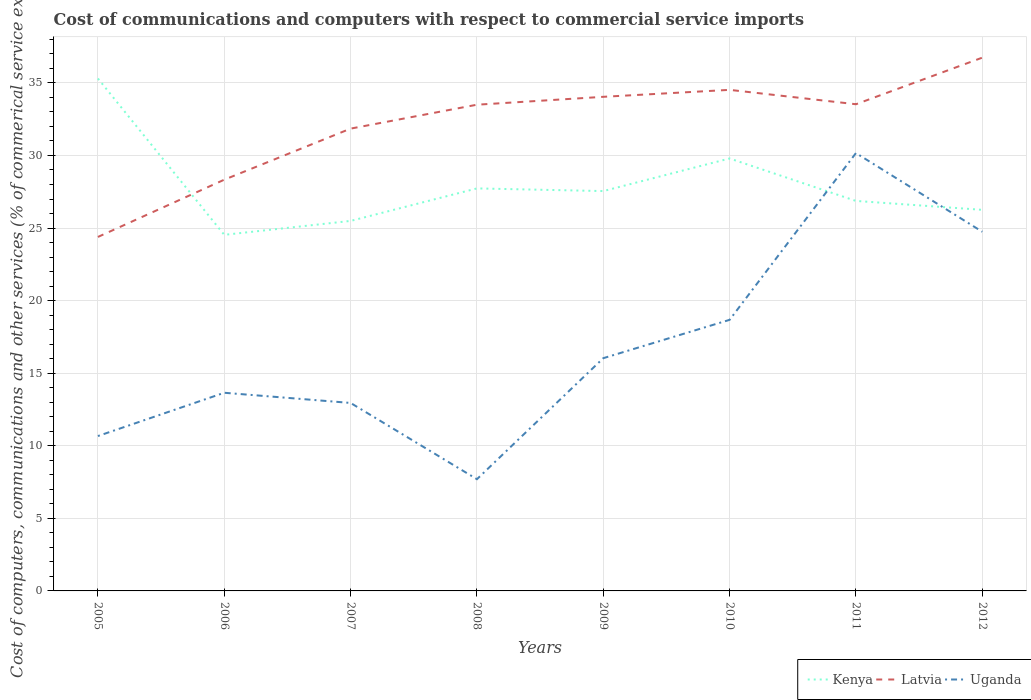Does the line corresponding to Latvia intersect with the line corresponding to Kenya?
Make the answer very short. Yes. Is the number of lines equal to the number of legend labels?
Ensure brevity in your answer.  Yes. Across all years, what is the maximum cost of communications and computers in Kenya?
Ensure brevity in your answer.  24.53. In which year was the cost of communications and computers in Kenya maximum?
Offer a terse response. 2006. What is the total cost of communications and computers in Kenya in the graph?
Your answer should be compact. -4.3. What is the difference between the highest and the second highest cost of communications and computers in Latvia?
Your answer should be very brief. 12.35. What is the difference between the highest and the lowest cost of communications and computers in Kenya?
Offer a very short reply. 2. How many lines are there?
Provide a short and direct response. 3. How many years are there in the graph?
Offer a very short reply. 8. Are the values on the major ticks of Y-axis written in scientific E-notation?
Your answer should be compact. No. How are the legend labels stacked?
Offer a very short reply. Horizontal. What is the title of the graph?
Your answer should be compact. Cost of communications and computers with respect to commercial service imports. What is the label or title of the X-axis?
Give a very brief answer. Years. What is the label or title of the Y-axis?
Provide a short and direct response. Cost of computers, communications and other services (% of commerical service exports). What is the Cost of computers, communications and other services (% of commerical service exports) of Kenya in 2005?
Your answer should be very brief. 35.3. What is the Cost of computers, communications and other services (% of commerical service exports) in Latvia in 2005?
Your response must be concise. 24.39. What is the Cost of computers, communications and other services (% of commerical service exports) in Uganda in 2005?
Offer a very short reply. 10.67. What is the Cost of computers, communications and other services (% of commerical service exports) of Kenya in 2006?
Offer a very short reply. 24.53. What is the Cost of computers, communications and other services (% of commerical service exports) in Latvia in 2006?
Keep it short and to the point. 28.33. What is the Cost of computers, communications and other services (% of commerical service exports) in Uganda in 2006?
Provide a succinct answer. 13.65. What is the Cost of computers, communications and other services (% of commerical service exports) of Kenya in 2007?
Your response must be concise. 25.49. What is the Cost of computers, communications and other services (% of commerical service exports) of Latvia in 2007?
Make the answer very short. 31.85. What is the Cost of computers, communications and other services (% of commerical service exports) of Uganda in 2007?
Provide a succinct answer. 12.95. What is the Cost of computers, communications and other services (% of commerical service exports) of Kenya in 2008?
Provide a succinct answer. 27.73. What is the Cost of computers, communications and other services (% of commerical service exports) of Latvia in 2008?
Provide a short and direct response. 33.5. What is the Cost of computers, communications and other services (% of commerical service exports) in Uganda in 2008?
Give a very brief answer. 7.7. What is the Cost of computers, communications and other services (% of commerical service exports) in Kenya in 2009?
Your response must be concise. 27.55. What is the Cost of computers, communications and other services (% of commerical service exports) in Latvia in 2009?
Keep it short and to the point. 34.04. What is the Cost of computers, communications and other services (% of commerical service exports) in Uganda in 2009?
Give a very brief answer. 16.03. What is the Cost of computers, communications and other services (% of commerical service exports) of Kenya in 2010?
Your answer should be very brief. 29.79. What is the Cost of computers, communications and other services (% of commerical service exports) of Latvia in 2010?
Make the answer very short. 34.52. What is the Cost of computers, communications and other services (% of commerical service exports) of Uganda in 2010?
Your answer should be very brief. 18.68. What is the Cost of computers, communications and other services (% of commerical service exports) of Kenya in 2011?
Keep it short and to the point. 26.87. What is the Cost of computers, communications and other services (% of commerical service exports) in Latvia in 2011?
Your response must be concise. 33.53. What is the Cost of computers, communications and other services (% of commerical service exports) in Uganda in 2011?
Your response must be concise. 30.17. What is the Cost of computers, communications and other services (% of commerical service exports) of Kenya in 2012?
Your response must be concise. 26.25. What is the Cost of computers, communications and other services (% of commerical service exports) of Latvia in 2012?
Provide a short and direct response. 36.74. What is the Cost of computers, communications and other services (% of commerical service exports) of Uganda in 2012?
Make the answer very short. 24.74. Across all years, what is the maximum Cost of computers, communications and other services (% of commerical service exports) of Kenya?
Provide a short and direct response. 35.3. Across all years, what is the maximum Cost of computers, communications and other services (% of commerical service exports) of Latvia?
Ensure brevity in your answer.  36.74. Across all years, what is the maximum Cost of computers, communications and other services (% of commerical service exports) in Uganda?
Offer a very short reply. 30.17. Across all years, what is the minimum Cost of computers, communications and other services (% of commerical service exports) in Kenya?
Offer a terse response. 24.53. Across all years, what is the minimum Cost of computers, communications and other services (% of commerical service exports) in Latvia?
Provide a succinct answer. 24.39. Across all years, what is the minimum Cost of computers, communications and other services (% of commerical service exports) in Uganda?
Offer a very short reply. 7.7. What is the total Cost of computers, communications and other services (% of commerical service exports) in Kenya in the graph?
Offer a very short reply. 223.52. What is the total Cost of computers, communications and other services (% of commerical service exports) in Latvia in the graph?
Your answer should be very brief. 256.89. What is the total Cost of computers, communications and other services (% of commerical service exports) in Uganda in the graph?
Give a very brief answer. 134.59. What is the difference between the Cost of computers, communications and other services (% of commerical service exports) in Kenya in 2005 and that in 2006?
Offer a very short reply. 10.77. What is the difference between the Cost of computers, communications and other services (% of commerical service exports) of Latvia in 2005 and that in 2006?
Ensure brevity in your answer.  -3.94. What is the difference between the Cost of computers, communications and other services (% of commerical service exports) of Uganda in 2005 and that in 2006?
Give a very brief answer. -2.98. What is the difference between the Cost of computers, communications and other services (% of commerical service exports) of Kenya in 2005 and that in 2007?
Ensure brevity in your answer.  9.81. What is the difference between the Cost of computers, communications and other services (% of commerical service exports) of Latvia in 2005 and that in 2007?
Provide a short and direct response. -7.46. What is the difference between the Cost of computers, communications and other services (% of commerical service exports) of Uganda in 2005 and that in 2007?
Keep it short and to the point. -2.28. What is the difference between the Cost of computers, communications and other services (% of commerical service exports) in Kenya in 2005 and that in 2008?
Ensure brevity in your answer.  7.57. What is the difference between the Cost of computers, communications and other services (% of commerical service exports) of Latvia in 2005 and that in 2008?
Offer a very short reply. -9.11. What is the difference between the Cost of computers, communications and other services (% of commerical service exports) of Uganda in 2005 and that in 2008?
Offer a very short reply. 2.97. What is the difference between the Cost of computers, communications and other services (% of commerical service exports) in Kenya in 2005 and that in 2009?
Keep it short and to the point. 7.75. What is the difference between the Cost of computers, communications and other services (% of commerical service exports) of Latvia in 2005 and that in 2009?
Your response must be concise. -9.65. What is the difference between the Cost of computers, communications and other services (% of commerical service exports) of Uganda in 2005 and that in 2009?
Provide a short and direct response. -5.36. What is the difference between the Cost of computers, communications and other services (% of commerical service exports) of Kenya in 2005 and that in 2010?
Your answer should be compact. 5.51. What is the difference between the Cost of computers, communications and other services (% of commerical service exports) of Latvia in 2005 and that in 2010?
Your answer should be very brief. -10.13. What is the difference between the Cost of computers, communications and other services (% of commerical service exports) of Uganda in 2005 and that in 2010?
Provide a short and direct response. -8.01. What is the difference between the Cost of computers, communications and other services (% of commerical service exports) of Kenya in 2005 and that in 2011?
Ensure brevity in your answer.  8.43. What is the difference between the Cost of computers, communications and other services (% of commerical service exports) in Latvia in 2005 and that in 2011?
Offer a very short reply. -9.14. What is the difference between the Cost of computers, communications and other services (% of commerical service exports) in Uganda in 2005 and that in 2011?
Make the answer very short. -19.5. What is the difference between the Cost of computers, communications and other services (% of commerical service exports) of Kenya in 2005 and that in 2012?
Provide a succinct answer. 9.05. What is the difference between the Cost of computers, communications and other services (% of commerical service exports) in Latvia in 2005 and that in 2012?
Offer a terse response. -12.35. What is the difference between the Cost of computers, communications and other services (% of commerical service exports) in Uganda in 2005 and that in 2012?
Your answer should be compact. -14.07. What is the difference between the Cost of computers, communications and other services (% of commerical service exports) in Kenya in 2006 and that in 2007?
Your answer should be very brief. -0.96. What is the difference between the Cost of computers, communications and other services (% of commerical service exports) of Latvia in 2006 and that in 2007?
Give a very brief answer. -3.52. What is the difference between the Cost of computers, communications and other services (% of commerical service exports) of Uganda in 2006 and that in 2007?
Your response must be concise. 0.7. What is the difference between the Cost of computers, communications and other services (% of commerical service exports) in Kenya in 2006 and that in 2008?
Offer a very short reply. -3.2. What is the difference between the Cost of computers, communications and other services (% of commerical service exports) of Latvia in 2006 and that in 2008?
Keep it short and to the point. -5.17. What is the difference between the Cost of computers, communications and other services (% of commerical service exports) of Uganda in 2006 and that in 2008?
Your answer should be very brief. 5.95. What is the difference between the Cost of computers, communications and other services (% of commerical service exports) in Kenya in 2006 and that in 2009?
Offer a very short reply. -3.02. What is the difference between the Cost of computers, communications and other services (% of commerical service exports) of Latvia in 2006 and that in 2009?
Make the answer very short. -5.71. What is the difference between the Cost of computers, communications and other services (% of commerical service exports) in Uganda in 2006 and that in 2009?
Provide a short and direct response. -2.38. What is the difference between the Cost of computers, communications and other services (% of commerical service exports) in Kenya in 2006 and that in 2010?
Offer a very short reply. -5.26. What is the difference between the Cost of computers, communications and other services (% of commerical service exports) of Latvia in 2006 and that in 2010?
Offer a terse response. -6.19. What is the difference between the Cost of computers, communications and other services (% of commerical service exports) of Uganda in 2006 and that in 2010?
Your response must be concise. -5.02. What is the difference between the Cost of computers, communications and other services (% of commerical service exports) in Kenya in 2006 and that in 2011?
Provide a succinct answer. -2.34. What is the difference between the Cost of computers, communications and other services (% of commerical service exports) of Latvia in 2006 and that in 2011?
Give a very brief answer. -5.2. What is the difference between the Cost of computers, communications and other services (% of commerical service exports) of Uganda in 2006 and that in 2011?
Provide a succinct answer. -16.51. What is the difference between the Cost of computers, communications and other services (% of commerical service exports) in Kenya in 2006 and that in 2012?
Make the answer very short. -1.72. What is the difference between the Cost of computers, communications and other services (% of commerical service exports) in Latvia in 2006 and that in 2012?
Offer a very short reply. -8.41. What is the difference between the Cost of computers, communications and other services (% of commerical service exports) in Uganda in 2006 and that in 2012?
Provide a short and direct response. -11.09. What is the difference between the Cost of computers, communications and other services (% of commerical service exports) of Kenya in 2007 and that in 2008?
Provide a short and direct response. -2.24. What is the difference between the Cost of computers, communications and other services (% of commerical service exports) in Latvia in 2007 and that in 2008?
Provide a succinct answer. -1.65. What is the difference between the Cost of computers, communications and other services (% of commerical service exports) of Uganda in 2007 and that in 2008?
Your response must be concise. 5.25. What is the difference between the Cost of computers, communications and other services (% of commerical service exports) in Kenya in 2007 and that in 2009?
Make the answer very short. -2.06. What is the difference between the Cost of computers, communications and other services (% of commerical service exports) in Latvia in 2007 and that in 2009?
Offer a very short reply. -2.19. What is the difference between the Cost of computers, communications and other services (% of commerical service exports) of Uganda in 2007 and that in 2009?
Make the answer very short. -3.08. What is the difference between the Cost of computers, communications and other services (% of commerical service exports) in Kenya in 2007 and that in 2010?
Provide a short and direct response. -4.3. What is the difference between the Cost of computers, communications and other services (% of commerical service exports) of Latvia in 2007 and that in 2010?
Ensure brevity in your answer.  -2.67. What is the difference between the Cost of computers, communications and other services (% of commerical service exports) in Uganda in 2007 and that in 2010?
Your response must be concise. -5.73. What is the difference between the Cost of computers, communications and other services (% of commerical service exports) of Kenya in 2007 and that in 2011?
Provide a succinct answer. -1.38. What is the difference between the Cost of computers, communications and other services (% of commerical service exports) of Latvia in 2007 and that in 2011?
Your answer should be very brief. -1.68. What is the difference between the Cost of computers, communications and other services (% of commerical service exports) in Uganda in 2007 and that in 2011?
Your answer should be very brief. -17.22. What is the difference between the Cost of computers, communications and other services (% of commerical service exports) of Kenya in 2007 and that in 2012?
Make the answer very short. -0.76. What is the difference between the Cost of computers, communications and other services (% of commerical service exports) in Latvia in 2007 and that in 2012?
Make the answer very short. -4.89. What is the difference between the Cost of computers, communications and other services (% of commerical service exports) of Uganda in 2007 and that in 2012?
Provide a short and direct response. -11.79. What is the difference between the Cost of computers, communications and other services (% of commerical service exports) of Kenya in 2008 and that in 2009?
Offer a terse response. 0.18. What is the difference between the Cost of computers, communications and other services (% of commerical service exports) of Latvia in 2008 and that in 2009?
Give a very brief answer. -0.54. What is the difference between the Cost of computers, communications and other services (% of commerical service exports) of Uganda in 2008 and that in 2009?
Your response must be concise. -8.34. What is the difference between the Cost of computers, communications and other services (% of commerical service exports) of Kenya in 2008 and that in 2010?
Keep it short and to the point. -2.06. What is the difference between the Cost of computers, communications and other services (% of commerical service exports) in Latvia in 2008 and that in 2010?
Offer a very short reply. -1.02. What is the difference between the Cost of computers, communications and other services (% of commerical service exports) of Uganda in 2008 and that in 2010?
Your answer should be very brief. -10.98. What is the difference between the Cost of computers, communications and other services (% of commerical service exports) in Kenya in 2008 and that in 2011?
Give a very brief answer. 0.86. What is the difference between the Cost of computers, communications and other services (% of commerical service exports) of Latvia in 2008 and that in 2011?
Your answer should be very brief. -0.03. What is the difference between the Cost of computers, communications and other services (% of commerical service exports) of Uganda in 2008 and that in 2011?
Offer a very short reply. -22.47. What is the difference between the Cost of computers, communications and other services (% of commerical service exports) in Kenya in 2008 and that in 2012?
Give a very brief answer. 1.48. What is the difference between the Cost of computers, communications and other services (% of commerical service exports) in Latvia in 2008 and that in 2012?
Keep it short and to the point. -3.24. What is the difference between the Cost of computers, communications and other services (% of commerical service exports) of Uganda in 2008 and that in 2012?
Provide a short and direct response. -17.05. What is the difference between the Cost of computers, communications and other services (% of commerical service exports) of Kenya in 2009 and that in 2010?
Offer a very short reply. -2.25. What is the difference between the Cost of computers, communications and other services (% of commerical service exports) in Latvia in 2009 and that in 2010?
Your answer should be very brief. -0.48. What is the difference between the Cost of computers, communications and other services (% of commerical service exports) in Uganda in 2009 and that in 2010?
Keep it short and to the point. -2.64. What is the difference between the Cost of computers, communications and other services (% of commerical service exports) of Kenya in 2009 and that in 2011?
Your answer should be compact. 0.68. What is the difference between the Cost of computers, communications and other services (% of commerical service exports) in Latvia in 2009 and that in 2011?
Your response must be concise. 0.51. What is the difference between the Cost of computers, communications and other services (% of commerical service exports) in Uganda in 2009 and that in 2011?
Provide a short and direct response. -14.13. What is the difference between the Cost of computers, communications and other services (% of commerical service exports) of Kenya in 2009 and that in 2012?
Your answer should be compact. 1.29. What is the difference between the Cost of computers, communications and other services (% of commerical service exports) of Latvia in 2009 and that in 2012?
Your answer should be compact. -2.7. What is the difference between the Cost of computers, communications and other services (% of commerical service exports) of Uganda in 2009 and that in 2012?
Your answer should be compact. -8.71. What is the difference between the Cost of computers, communications and other services (% of commerical service exports) of Kenya in 2010 and that in 2011?
Offer a very short reply. 2.92. What is the difference between the Cost of computers, communications and other services (% of commerical service exports) of Latvia in 2010 and that in 2011?
Your answer should be very brief. 0.99. What is the difference between the Cost of computers, communications and other services (% of commerical service exports) in Uganda in 2010 and that in 2011?
Make the answer very short. -11.49. What is the difference between the Cost of computers, communications and other services (% of commerical service exports) in Kenya in 2010 and that in 2012?
Offer a very short reply. 3.54. What is the difference between the Cost of computers, communications and other services (% of commerical service exports) of Latvia in 2010 and that in 2012?
Your response must be concise. -2.22. What is the difference between the Cost of computers, communications and other services (% of commerical service exports) in Uganda in 2010 and that in 2012?
Your answer should be very brief. -6.07. What is the difference between the Cost of computers, communications and other services (% of commerical service exports) in Kenya in 2011 and that in 2012?
Keep it short and to the point. 0.61. What is the difference between the Cost of computers, communications and other services (% of commerical service exports) of Latvia in 2011 and that in 2012?
Make the answer very short. -3.21. What is the difference between the Cost of computers, communications and other services (% of commerical service exports) of Uganda in 2011 and that in 2012?
Ensure brevity in your answer.  5.42. What is the difference between the Cost of computers, communications and other services (% of commerical service exports) of Kenya in 2005 and the Cost of computers, communications and other services (% of commerical service exports) of Latvia in 2006?
Give a very brief answer. 6.97. What is the difference between the Cost of computers, communications and other services (% of commerical service exports) in Kenya in 2005 and the Cost of computers, communications and other services (% of commerical service exports) in Uganda in 2006?
Offer a very short reply. 21.65. What is the difference between the Cost of computers, communications and other services (% of commerical service exports) of Latvia in 2005 and the Cost of computers, communications and other services (% of commerical service exports) of Uganda in 2006?
Ensure brevity in your answer.  10.73. What is the difference between the Cost of computers, communications and other services (% of commerical service exports) of Kenya in 2005 and the Cost of computers, communications and other services (% of commerical service exports) of Latvia in 2007?
Provide a short and direct response. 3.45. What is the difference between the Cost of computers, communications and other services (% of commerical service exports) of Kenya in 2005 and the Cost of computers, communications and other services (% of commerical service exports) of Uganda in 2007?
Provide a short and direct response. 22.35. What is the difference between the Cost of computers, communications and other services (% of commerical service exports) of Latvia in 2005 and the Cost of computers, communications and other services (% of commerical service exports) of Uganda in 2007?
Your answer should be very brief. 11.44. What is the difference between the Cost of computers, communications and other services (% of commerical service exports) in Kenya in 2005 and the Cost of computers, communications and other services (% of commerical service exports) in Latvia in 2008?
Provide a short and direct response. 1.8. What is the difference between the Cost of computers, communications and other services (% of commerical service exports) of Kenya in 2005 and the Cost of computers, communications and other services (% of commerical service exports) of Uganda in 2008?
Make the answer very short. 27.6. What is the difference between the Cost of computers, communications and other services (% of commerical service exports) of Latvia in 2005 and the Cost of computers, communications and other services (% of commerical service exports) of Uganda in 2008?
Offer a terse response. 16.69. What is the difference between the Cost of computers, communications and other services (% of commerical service exports) of Kenya in 2005 and the Cost of computers, communications and other services (% of commerical service exports) of Latvia in 2009?
Your answer should be compact. 1.26. What is the difference between the Cost of computers, communications and other services (% of commerical service exports) of Kenya in 2005 and the Cost of computers, communications and other services (% of commerical service exports) of Uganda in 2009?
Ensure brevity in your answer.  19.27. What is the difference between the Cost of computers, communications and other services (% of commerical service exports) in Latvia in 2005 and the Cost of computers, communications and other services (% of commerical service exports) in Uganda in 2009?
Offer a terse response. 8.35. What is the difference between the Cost of computers, communications and other services (% of commerical service exports) in Kenya in 2005 and the Cost of computers, communications and other services (% of commerical service exports) in Latvia in 2010?
Provide a short and direct response. 0.78. What is the difference between the Cost of computers, communications and other services (% of commerical service exports) of Kenya in 2005 and the Cost of computers, communications and other services (% of commerical service exports) of Uganda in 2010?
Offer a very short reply. 16.63. What is the difference between the Cost of computers, communications and other services (% of commerical service exports) of Latvia in 2005 and the Cost of computers, communications and other services (% of commerical service exports) of Uganda in 2010?
Give a very brief answer. 5.71. What is the difference between the Cost of computers, communications and other services (% of commerical service exports) of Kenya in 2005 and the Cost of computers, communications and other services (% of commerical service exports) of Latvia in 2011?
Provide a succinct answer. 1.77. What is the difference between the Cost of computers, communications and other services (% of commerical service exports) in Kenya in 2005 and the Cost of computers, communications and other services (% of commerical service exports) in Uganda in 2011?
Keep it short and to the point. 5.14. What is the difference between the Cost of computers, communications and other services (% of commerical service exports) in Latvia in 2005 and the Cost of computers, communications and other services (% of commerical service exports) in Uganda in 2011?
Make the answer very short. -5.78. What is the difference between the Cost of computers, communications and other services (% of commerical service exports) of Kenya in 2005 and the Cost of computers, communications and other services (% of commerical service exports) of Latvia in 2012?
Keep it short and to the point. -1.44. What is the difference between the Cost of computers, communications and other services (% of commerical service exports) of Kenya in 2005 and the Cost of computers, communications and other services (% of commerical service exports) of Uganda in 2012?
Make the answer very short. 10.56. What is the difference between the Cost of computers, communications and other services (% of commerical service exports) in Latvia in 2005 and the Cost of computers, communications and other services (% of commerical service exports) in Uganda in 2012?
Give a very brief answer. -0.36. What is the difference between the Cost of computers, communications and other services (% of commerical service exports) of Kenya in 2006 and the Cost of computers, communications and other services (% of commerical service exports) of Latvia in 2007?
Offer a terse response. -7.32. What is the difference between the Cost of computers, communications and other services (% of commerical service exports) in Kenya in 2006 and the Cost of computers, communications and other services (% of commerical service exports) in Uganda in 2007?
Give a very brief answer. 11.58. What is the difference between the Cost of computers, communications and other services (% of commerical service exports) of Latvia in 2006 and the Cost of computers, communications and other services (% of commerical service exports) of Uganda in 2007?
Provide a short and direct response. 15.38. What is the difference between the Cost of computers, communications and other services (% of commerical service exports) of Kenya in 2006 and the Cost of computers, communications and other services (% of commerical service exports) of Latvia in 2008?
Give a very brief answer. -8.97. What is the difference between the Cost of computers, communications and other services (% of commerical service exports) of Kenya in 2006 and the Cost of computers, communications and other services (% of commerical service exports) of Uganda in 2008?
Your answer should be compact. 16.83. What is the difference between the Cost of computers, communications and other services (% of commerical service exports) of Latvia in 2006 and the Cost of computers, communications and other services (% of commerical service exports) of Uganda in 2008?
Offer a very short reply. 20.63. What is the difference between the Cost of computers, communications and other services (% of commerical service exports) in Kenya in 2006 and the Cost of computers, communications and other services (% of commerical service exports) in Latvia in 2009?
Ensure brevity in your answer.  -9.51. What is the difference between the Cost of computers, communications and other services (% of commerical service exports) of Kenya in 2006 and the Cost of computers, communications and other services (% of commerical service exports) of Uganda in 2009?
Your answer should be very brief. 8.5. What is the difference between the Cost of computers, communications and other services (% of commerical service exports) in Latvia in 2006 and the Cost of computers, communications and other services (% of commerical service exports) in Uganda in 2009?
Offer a very short reply. 12.3. What is the difference between the Cost of computers, communications and other services (% of commerical service exports) in Kenya in 2006 and the Cost of computers, communications and other services (% of commerical service exports) in Latvia in 2010?
Offer a terse response. -9.99. What is the difference between the Cost of computers, communications and other services (% of commerical service exports) in Kenya in 2006 and the Cost of computers, communications and other services (% of commerical service exports) in Uganda in 2010?
Offer a very short reply. 5.86. What is the difference between the Cost of computers, communications and other services (% of commerical service exports) of Latvia in 2006 and the Cost of computers, communications and other services (% of commerical service exports) of Uganda in 2010?
Offer a terse response. 9.65. What is the difference between the Cost of computers, communications and other services (% of commerical service exports) in Kenya in 2006 and the Cost of computers, communications and other services (% of commerical service exports) in Latvia in 2011?
Offer a very short reply. -9. What is the difference between the Cost of computers, communications and other services (% of commerical service exports) of Kenya in 2006 and the Cost of computers, communications and other services (% of commerical service exports) of Uganda in 2011?
Ensure brevity in your answer.  -5.63. What is the difference between the Cost of computers, communications and other services (% of commerical service exports) in Latvia in 2006 and the Cost of computers, communications and other services (% of commerical service exports) in Uganda in 2011?
Give a very brief answer. -1.83. What is the difference between the Cost of computers, communications and other services (% of commerical service exports) in Kenya in 2006 and the Cost of computers, communications and other services (% of commerical service exports) in Latvia in 2012?
Ensure brevity in your answer.  -12.21. What is the difference between the Cost of computers, communications and other services (% of commerical service exports) of Kenya in 2006 and the Cost of computers, communications and other services (% of commerical service exports) of Uganda in 2012?
Your answer should be very brief. -0.21. What is the difference between the Cost of computers, communications and other services (% of commerical service exports) in Latvia in 2006 and the Cost of computers, communications and other services (% of commerical service exports) in Uganda in 2012?
Your response must be concise. 3.59. What is the difference between the Cost of computers, communications and other services (% of commerical service exports) in Kenya in 2007 and the Cost of computers, communications and other services (% of commerical service exports) in Latvia in 2008?
Your answer should be very brief. -8.01. What is the difference between the Cost of computers, communications and other services (% of commerical service exports) in Kenya in 2007 and the Cost of computers, communications and other services (% of commerical service exports) in Uganda in 2008?
Your answer should be compact. 17.79. What is the difference between the Cost of computers, communications and other services (% of commerical service exports) of Latvia in 2007 and the Cost of computers, communications and other services (% of commerical service exports) of Uganda in 2008?
Provide a short and direct response. 24.15. What is the difference between the Cost of computers, communications and other services (% of commerical service exports) of Kenya in 2007 and the Cost of computers, communications and other services (% of commerical service exports) of Latvia in 2009?
Offer a terse response. -8.55. What is the difference between the Cost of computers, communications and other services (% of commerical service exports) of Kenya in 2007 and the Cost of computers, communications and other services (% of commerical service exports) of Uganda in 2009?
Offer a very short reply. 9.46. What is the difference between the Cost of computers, communications and other services (% of commerical service exports) in Latvia in 2007 and the Cost of computers, communications and other services (% of commerical service exports) in Uganda in 2009?
Give a very brief answer. 15.82. What is the difference between the Cost of computers, communications and other services (% of commerical service exports) of Kenya in 2007 and the Cost of computers, communications and other services (% of commerical service exports) of Latvia in 2010?
Your response must be concise. -9.03. What is the difference between the Cost of computers, communications and other services (% of commerical service exports) of Kenya in 2007 and the Cost of computers, communications and other services (% of commerical service exports) of Uganda in 2010?
Your answer should be very brief. 6.82. What is the difference between the Cost of computers, communications and other services (% of commerical service exports) in Latvia in 2007 and the Cost of computers, communications and other services (% of commerical service exports) in Uganda in 2010?
Provide a short and direct response. 13.17. What is the difference between the Cost of computers, communications and other services (% of commerical service exports) of Kenya in 2007 and the Cost of computers, communications and other services (% of commerical service exports) of Latvia in 2011?
Offer a very short reply. -8.04. What is the difference between the Cost of computers, communications and other services (% of commerical service exports) in Kenya in 2007 and the Cost of computers, communications and other services (% of commerical service exports) in Uganda in 2011?
Give a very brief answer. -4.67. What is the difference between the Cost of computers, communications and other services (% of commerical service exports) in Latvia in 2007 and the Cost of computers, communications and other services (% of commerical service exports) in Uganda in 2011?
Provide a short and direct response. 1.68. What is the difference between the Cost of computers, communications and other services (% of commerical service exports) of Kenya in 2007 and the Cost of computers, communications and other services (% of commerical service exports) of Latvia in 2012?
Make the answer very short. -11.25. What is the difference between the Cost of computers, communications and other services (% of commerical service exports) of Kenya in 2007 and the Cost of computers, communications and other services (% of commerical service exports) of Uganda in 2012?
Ensure brevity in your answer.  0.75. What is the difference between the Cost of computers, communications and other services (% of commerical service exports) of Latvia in 2007 and the Cost of computers, communications and other services (% of commerical service exports) of Uganda in 2012?
Give a very brief answer. 7.11. What is the difference between the Cost of computers, communications and other services (% of commerical service exports) of Kenya in 2008 and the Cost of computers, communications and other services (% of commerical service exports) of Latvia in 2009?
Ensure brevity in your answer.  -6.31. What is the difference between the Cost of computers, communications and other services (% of commerical service exports) of Kenya in 2008 and the Cost of computers, communications and other services (% of commerical service exports) of Uganda in 2009?
Offer a very short reply. 11.7. What is the difference between the Cost of computers, communications and other services (% of commerical service exports) of Latvia in 2008 and the Cost of computers, communications and other services (% of commerical service exports) of Uganda in 2009?
Make the answer very short. 17.46. What is the difference between the Cost of computers, communications and other services (% of commerical service exports) in Kenya in 2008 and the Cost of computers, communications and other services (% of commerical service exports) in Latvia in 2010?
Offer a very short reply. -6.79. What is the difference between the Cost of computers, communications and other services (% of commerical service exports) of Kenya in 2008 and the Cost of computers, communications and other services (% of commerical service exports) of Uganda in 2010?
Provide a succinct answer. 9.05. What is the difference between the Cost of computers, communications and other services (% of commerical service exports) in Latvia in 2008 and the Cost of computers, communications and other services (% of commerical service exports) in Uganda in 2010?
Offer a terse response. 14.82. What is the difference between the Cost of computers, communications and other services (% of commerical service exports) of Kenya in 2008 and the Cost of computers, communications and other services (% of commerical service exports) of Latvia in 2011?
Your answer should be very brief. -5.8. What is the difference between the Cost of computers, communications and other services (% of commerical service exports) of Kenya in 2008 and the Cost of computers, communications and other services (% of commerical service exports) of Uganda in 2011?
Provide a short and direct response. -2.43. What is the difference between the Cost of computers, communications and other services (% of commerical service exports) in Latvia in 2008 and the Cost of computers, communications and other services (% of commerical service exports) in Uganda in 2011?
Offer a terse response. 3.33. What is the difference between the Cost of computers, communications and other services (% of commerical service exports) of Kenya in 2008 and the Cost of computers, communications and other services (% of commerical service exports) of Latvia in 2012?
Offer a very short reply. -9.01. What is the difference between the Cost of computers, communications and other services (% of commerical service exports) of Kenya in 2008 and the Cost of computers, communications and other services (% of commerical service exports) of Uganda in 2012?
Your answer should be very brief. 2.99. What is the difference between the Cost of computers, communications and other services (% of commerical service exports) of Latvia in 2008 and the Cost of computers, communications and other services (% of commerical service exports) of Uganda in 2012?
Provide a succinct answer. 8.75. What is the difference between the Cost of computers, communications and other services (% of commerical service exports) of Kenya in 2009 and the Cost of computers, communications and other services (% of commerical service exports) of Latvia in 2010?
Make the answer very short. -6.97. What is the difference between the Cost of computers, communications and other services (% of commerical service exports) of Kenya in 2009 and the Cost of computers, communications and other services (% of commerical service exports) of Uganda in 2010?
Provide a succinct answer. 8.87. What is the difference between the Cost of computers, communications and other services (% of commerical service exports) in Latvia in 2009 and the Cost of computers, communications and other services (% of commerical service exports) in Uganda in 2010?
Provide a short and direct response. 15.37. What is the difference between the Cost of computers, communications and other services (% of commerical service exports) in Kenya in 2009 and the Cost of computers, communications and other services (% of commerical service exports) in Latvia in 2011?
Your response must be concise. -5.98. What is the difference between the Cost of computers, communications and other services (% of commerical service exports) in Kenya in 2009 and the Cost of computers, communications and other services (% of commerical service exports) in Uganda in 2011?
Ensure brevity in your answer.  -2.62. What is the difference between the Cost of computers, communications and other services (% of commerical service exports) of Latvia in 2009 and the Cost of computers, communications and other services (% of commerical service exports) of Uganda in 2011?
Make the answer very short. 3.88. What is the difference between the Cost of computers, communications and other services (% of commerical service exports) in Kenya in 2009 and the Cost of computers, communications and other services (% of commerical service exports) in Latvia in 2012?
Your response must be concise. -9.19. What is the difference between the Cost of computers, communications and other services (% of commerical service exports) of Kenya in 2009 and the Cost of computers, communications and other services (% of commerical service exports) of Uganda in 2012?
Offer a terse response. 2.8. What is the difference between the Cost of computers, communications and other services (% of commerical service exports) of Latvia in 2009 and the Cost of computers, communications and other services (% of commerical service exports) of Uganda in 2012?
Ensure brevity in your answer.  9.3. What is the difference between the Cost of computers, communications and other services (% of commerical service exports) in Kenya in 2010 and the Cost of computers, communications and other services (% of commerical service exports) in Latvia in 2011?
Your answer should be very brief. -3.74. What is the difference between the Cost of computers, communications and other services (% of commerical service exports) in Kenya in 2010 and the Cost of computers, communications and other services (% of commerical service exports) in Uganda in 2011?
Give a very brief answer. -0.37. What is the difference between the Cost of computers, communications and other services (% of commerical service exports) of Latvia in 2010 and the Cost of computers, communications and other services (% of commerical service exports) of Uganda in 2011?
Provide a short and direct response. 4.35. What is the difference between the Cost of computers, communications and other services (% of commerical service exports) of Kenya in 2010 and the Cost of computers, communications and other services (% of commerical service exports) of Latvia in 2012?
Your response must be concise. -6.95. What is the difference between the Cost of computers, communications and other services (% of commerical service exports) of Kenya in 2010 and the Cost of computers, communications and other services (% of commerical service exports) of Uganda in 2012?
Provide a short and direct response. 5.05. What is the difference between the Cost of computers, communications and other services (% of commerical service exports) in Latvia in 2010 and the Cost of computers, communications and other services (% of commerical service exports) in Uganda in 2012?
Keep it short and to the point. 9.78. What is the difference between the Cost of computers, communications and other services (% of commerical service exports) of Kenya in 2011 and the Cost of computers, communications and other services (% of commerical service exports) of Latvia in 2012?
Your response must be concise. -9.87. What is the difference between the Cost of computers, communications and other services (% of commerical service exports) of Kenya in 2011 and the Cost of computers, communications and other services (% of commerical service exports) of Uganda in 2012?
Your response must be concise. 2.12. What is the difference between the Cost of computers, communications and other services (% of commerical service exports) of Latvia in 2011 and the Cost of computers, communications and other services (% of commerical service exports) of Uganda in 2012?
Offer a very short reply. 8.78. What is the average Cost of computers, communications and other services (% of commerical service exports) in Kenya per year?
Ensure brevity in your answer.  27.94. What is the average Cost of computers, communications and other services (% of commerical service exports) in Latvia per year?
Ensure brevity in your answer.  32.11. What is the average Cost of computers, communications and other services (% of commerical service exports) in Uganda per year?
Offer a very short reply. 16.82. In the year 2005, what is the difference between the Cost of computers, communications and other services (% of commerical service exports) in Kenya and Cost of computers, communications and other services (% of commerical service exports) in Latvia?
Make the answer very short. 10.92. In the year 2005, what is the difference between the Cost of computers, communications and other services (% of commerical service exports) in Kenya and Cost of computers, communications and other services (% of commerical service exports) in Uganda?
Ensure brevity in your answer.  24.63. In the year 2005, what is the difference between the Cost of computers, communications and other services (% of commerical service exports) in Latvia and Cost of computers, communications and other services (% of commerical service exports) in Uganda?
Your answer should be very brief. 13.72. In the year 2006, what is the difference between the Cost of computers, communications and other services (% of commerical service exports) in Kenya and Cost of computers, communications and other services (% of commerical service exports) in Latvia?
Provide a short and direct response. -3.8. In the year 2006, what is the difference between the Cost of computers, communications and other services (% of commerical service exports) in Kenya and Cost of computers, communications and other services (% of commerical service exports) in Uganda?
Provide a short and direct response. 10.88. In the year 2006, what is the difference between the Cost of computers, communications and other services (% of commerical service exports) of Latvia and Cost of computers, communications and other services (% of commerical service exports) of Uganda?
Your answer should be compact. 14.68. In the year 2007, what is the difference between the Cost of computers, communications and other services (% of commerical service exports) in Kenya and Cost of computers, communications and other services (% of commerical service exports) in Latvia?
Ensure brevity in your answer.  -6.36. In the year 2007, what is the difference between the Cost of computers, communications and other services (% of commerical service exports) of Kenya and Cost of computers, communications and other services (% of commerical service exports) of Uganda?
Offer a very short reply. 12.54. In the year 2007, what is the difference between the Cost of computers, communications and other services (% of commerical service exports) of Latvia and Cost of computers, communications and other services (% of commerical service exports) of Uganda?
Give a very brief answer. 18.9. In the year 2008, what is the difference between the Cost of computers, communications and other services (% of commerical service exports) in Kenya and Cost of computers, communications and other services (% of commerical service exports) in Latvia?
Provide a short and direct response. -5.77. In the year 2008, what is the difference between the Cost of computers, communications and other services (% of commerical service exports) of Kenya and Cost of computers, communications and other services (% of commerical service exports) of Uganda?
Make the answer very short. 20.03. In the year 2008, what is the difference between the Cost of computers, communications and other services (% of commerical service exports) in Latvia and Cost of computers, communications and other services (% of commerical service exports) in Uganda?
Provide a succinct answer. 25.8. In the year 2009, what is the difference between the Cost of computers, communications and other services (% of commerical service exports) in Kenya and Cost of computers, communications and other services (% of commerical service exports) in Latvia?
Offer a very short reply. -6.49. In the year 2009, what is the difference between the Cost of computers, communications and other services (% of commerical service exports) in Kenya and Cost of computers, communications and other services (% of commerical service exports) in Uganda?
Give a very brief answer. 11.51. In the year 2009, what is the difference between the Cost of computers, communications and other services (% of commerical service exports) of Latvia and Cost of computers, communications and other services (% of commerical service exports) of Uganda?
Ensure brevity in your answer.  18.01. In the year 2010, what is the difference between the Cost of computers, communications and other services (% of commerical service exports) in Kenya and Cost of computers, communications and other services (% of commerical service exports) in Latvia?
Provide a short and direct response. -4.73. In the year 2010, what is the difference between the Cost of computers, communications and other services (% of commerical service exports) in Kenya and Cost of computers, communications and other services (% of commerical service exports) in Uganda?
Give a very brief answer. 11.12. In the year 2010, what is the difference between the Cost of computers, communications and other services (% of commerical service exports) in Latvia and Cost of computers, communications and other services (% of commerical service exports) in Uganda?
Your answer should be very brief. 15.84. In the year 2011, what is the difference between the Cost of computers, communications and other services (% of commerical service exports) in Kenya and Cost of computers, communications and other services (% of commerical service exports) in Latvia?
Ensure brevity in your answer.  -6.66. In the year 2011, what is the difference between the Cost of computers, communications and other services (% of commerical service exports) of Kenya and Cost of computers, communications and other services (% of commerical service exports) of Uganda?
Offer a very short reply. -3.3. In the year 2011, what is the difference between the Cost of computers, communications and other services (% of commerical service exports) of Latvia and Cost of computers, communications and other services (% of commerical service exports) of Uganda?
Make the answer very short. 3.36. In the year 2012, what is the difference between the Cost of computers, communications and other services (% of commerical service exports) of Kenya and Cost of computers, communications and other services (% of commerical service exports) of Latvia?
Offer a very short reply. -10.48. In the year 2012, what is the difference between the Cost of computers, communications and other services (% of commerical service exports) of Kenya and Cost of computers, communications and other services (% of commerical service exports) of Uganda?
Offer a terse response. 1.51. In the year 2012, what is the difference between the Cost of computers, communications and other services (% of commerical service exports) in Latvia and Cost of computers, communications and other services (% of commerical service exports) in Uganda?
Your response must be concise. 11.99. What is the ratio of the Cost of computers, communications and other services (% of commerical service exports) in Kenya in 2005 to that in 2006?
Ensure brevity in your answer.  1.44. What is the ratio of the Cost of computers, communications and other services (% of commerical service exports) of Latvia in 2005 to that in 2006?
Make the answer very short. 0.86. What is the ratio of the Cost of computers, communications and other services (% of commerical service exports) of Uganda in 2005 to that in 2006?
Provide a succinct answer. 0.78. What is the ratio of the Cost of computers, communications and other services (% of commerical service exports) in Kenya in 2005 to that in 2007?
Your answer should be compact. 1.38. What is the ratio of the Cost of computers, communications and other services (% of commerical service exports) in Latvia in 2005 to that in 2007?
Your answer should be compact. 0.77. What is the ratio of the Cost of computers, communications and other services (% of commerical service exports) of Uganda in 2005 to that in 2007?
Your answer should be very brief. 0.82. What is the ratio of the Cost of computers, communications and other services (% of commerical service exports) of Kenya in 2005 to that in 2008?
Keep it short and to the point. 1.27. What is the ratio of the Cost of computers, communications and other services (% of commerical service exports) of Latvia in 2005 to that in 2008?
Your answer should be very brief. 0.73. What is the ratio of the Cost of computers, communications and other services (% of commerical service exports) in Uganda in 2005 to that in 2008?
Your response must be concise. 1.39. What is the ratio of the Cost of computers, communications and other services (% of commerical service exports) of Kenya in 2005 to that in 2009?
Your response must be concise. 1.28. What is the ratio of the Cost of computers, communications and other services (% of commerical service exports) of Latvia in 2005 to that in 2009?
Keep it short and to the point. 0.72. What is the ratio of the Cost of computers, communications and other services (% of commerical service exports) in Uganda in 2005 to that in 2009?
Ensure brevity in your answer.  0.67. What is the ratio of the Cost of computers, communications and other services (% of commerical service exports) in Kenya in 2005 to that in 2010?
Make the answer very short. 1.18. What is the ratio of the Cost of computers, communications and other services (% of commerical service exports) in Latvia in 2005 to that in 2010?
Offer a very short reply. 0.71. What is the ratio of the Cost of computers, communications and other services (% of commerical service exports) in Uganda in 2005 to that in 2010?
Ensure brevity in your answer.  0.57. What is the ratio of the Cost of computers, communications and other services (% of commerical service exports) of Kenya in 2005 to that in 2011?
Your response must be concise. 1.31. What is the ratio of the Cost of computers, communications and other services (% of commerical service exports) in Latvia in 2005 to that in 2011?
Ensure brevity in your answer.  0.73. What is the ratio of the Cost of computers, communications and other services (% of commerical service exports) in Uganda in 2005 to that in 2011?
Make the answer very short. 0.35. What is the ratio of the Cost of computers, communications and other services (% of commerical service exports) of Kenya in 2005 to that in 2012?
Provide a short and direct response. 1.34. What is the ratio of the Cost of computers, communications and other services (% of commerical service exports) in Latvia in 2005 to that in 2012?
Keep it short and to the point. 0.66. What is the ratio of the Cost of computers, communications and other services (% of commerical service exports) in Uganda in 2005 to that in 2012?
Make the answer very short. 0.43. What is the ratio of the Cost of computers, communications and other services (% of commerical service exports) in Kenya in 2006 to that in 2007?
Your answer should be compact. 0.96. What is the ratio of the Cost of computers, communications and other services (% of commerical service exports) of Latvia in 2006 to that in 2007?
Offer a very short reply. 0.89. What is the ratio of the Cost of computers, communications and other services (% of commerical service exports) in Uganda in 2006 to that in 2007?
Make the answer very short. 1.05. What is the ratio of the Cost of computers, communications and other services (% of commerical service exports) of Kenya in 2006 to that in 2008?
Offer a very short reply. 0.88. What is the ratio of the Cost of computers, communications and other services (% of commerical service exports) of Latvia in 2006 to that in 2008?
Give a very brief answer. 0.85. What is the ratio of the Cost of computers, communications and other services (% of commerical service exports) of Uganda in 2006 to that in 2008?
Your answer should be very brief. 1.77. What is the ratio of the Cost of computers, communications and other services (% of commerical service exports) in Kenya in 2006 to that in 2009?
Your answer should be compact. 0.89. What is the ratio of the Cost of computers, communications and other services (% of commerical service exports) in Latvia in 2006 to that in 2009?
Your answer should be very brief. 0.83. What is the ratio of the Cost of computers, communications and other services (% of commerical service exports) in Uganda in 2006 to that in 2009?
Your response must be concise. 0.85. What is the ratio of the Cost of computers, communications and other services (% of commerical service exports) of Kenya in 2006 to that in 2010?
Your response must be concise. 0.82. What is the ratio of the Cost of computers, communications and other services (% of commerical service exports) in Latvia in 2006 to that in 2010?
Your response must be concise. 0.82. What is the ratio of the Cost of computers, communications and other services (% of commerical service exports) of Uganda in 2006 to that in 2010?
Offer a very short reply. 0.73. What is the ratio of the Cost of computers, communications and other services (% of commerical service exports) of Kenya in 2006 to that in 2011?
Ensure brevity in your answer.  0.91. What is the ratio of the Cost of computers, communications and other services (% of commerical service exports) in Latvia in 2006 to that in 2011?
Give a very brief answer. 0.84. What is the ratio of the Cost of computers, communications and other services (% of commerical service exports) of Uganda in 2006 to that in 2011?
Give a very brief answer. 0.45. What is the ratio of the Cost of computers, communications and other services (% of commerical service exports) of Kenya in 2006 to that in 2012?
Provide a short and direct response. 0.93. What is the ratio of the Cost of computers, communications and other services (% of commerical service exports) of Latvia in 2006 to that in 2012?
Provide a succinct answer. 0.77. What is the ratio of the Cost of computers, communications and other services (% of commerical service exports) in Uganda in 2006 to that in 2012?
Ensure brevity in your answer.  0.55. What is the ratio of the Cost of computers, communications and other services (% of commerical service exports) of Kenya in 2007 to that in 2008?
Your answer should be compact. 0.92. What is the ratio of the Cost of computers, communications and other services (% of commerical service exports) in Latvia in 2007 to that in 2008?
Offer a very short reply. 0.95. What is the ratio of the Cost of computers, communications and other services (% of commerical service exports) of Uganda in 2007 to that in 2008?
Give a very brief answer. 1.68. What is the ratio of the Cost of computers, communications and other services (% of commerical service exports) of Kenya in 2007 to that in 2009?
Provide a succinct answer. 0.93. What is the ratio of the Cost of computers, communications and other services (% of commerical service exports) in Latvia in 2007 to that in 2009?
Provide a succinct answer. 0.94. What is the ratio of the Cost of computers, communications and other services (% of commerical service exports) in Uganda in 2007 to that in 2009?
Ensure brevity in your answer.  0.81. What is the ratio of the Cost of computers, communications and other services (% of commerical service exports) of Kenya in 2007 to that in 2010?
Provide a succinct answer. 0.86. What is the ratio of the Cost of computers, communications and other services (% of commerical service exports) in Latvia in 2007 to that in 2010?
Your answer should be compact. 0.92. What is the ratio of the Cost of computers, communications and other services (% of commerical service exports) of Uganda in 2007 to that in 2010?
Provide a short and direct response. 0.69. What is the ratio of the Cost of computers, communications and other services (% of commerical service exports) of Kenya in 2007 to that in 2011?
Provide a short and direct response. 0.95. What is the ratio of the Cost of computers, communications and other services (% of commerical service exports) of Latvia in 2007 to that in 2011?
Offer a terse response. 0.95. What is the ratio of the Cost of computers, communications and other services (% of commerical service exports) in Uganda in 2007 to that in 2011?
Ensure brevity in your answer.  0.43. What is the ratio of the Cost of computers, communications and other services (% of commerical service exports) in Kenya in 2007 to that in 2012?
Offer a terse response. 0.97. What is the ratio of the Cost of computers, communications and other services (% of commerical service exports) in Latvia in 2007 to that in 2012?
Offer a terse response. 0.87. What is the ratio of the Cost of computers, communications and other services (% of commerical service exports) in Uganda in 2007 to that in 2012?
Your response must be concise. 0.52. What is the ratio of the Cost of computers, communications and other services (% of commerical service exports) of Kenya in 2008 to that in 2009?
Your response must be concise. 1.01. What is the ratio of the Cost of computers, communications and other services (% of commerical service exports) in Uganda in 2008 to that in 2009?
Keep it short and to the point. 0.48. What is the ratio of the Cost of computers, communications and other services (% of commerical service exports) of Kenya in 2008 to that in 2010?
Give a very brief answer. 0.93. What is the ratio of the Cost of computers, communications and other services (% of commerical service exports) of Latvia in 2008 to that in 2010?
Your answer should be very brief. 0.97. What is the ratio of the Cost of computers, communications and other services (% of commerical service exports) in Uganda in 2008 to that in 2010?
Your response must be concise. 0.41. What is the ratio of the Cost of computers, communications and other services (% of commerical service exports) in Kenya in 2008 to that in 2011?
Ensure brevity in your answer.  1.03. What is the ratio of the Cost of computers, communications and other services (% of commerical service exports) of Uganda in 2008 to that in 2011?
Your answer should be compact. 0.26. What is the ratio of the Cost of computers, communications and other services (% of commerical service exports) of Kenya in 2008 to that in 2012?
Offer a terse response. 1.06. What is the ratio of the Cost of computers, communications and other services (% of commerical service exports) in Latvia in 2008 to that in 2012?
Your answer should be compact. 0.91. What is the ratio of the Cost of computers, communications and other services (% of commerical service exports) in Uganda in 2008 to that in 2012?
Keep it short and to the point. 0.31. What is the ratio of the Cost of computers, communications and other services (% of commerical service exports) in Kenya in 2009 to that in 2010?
Offer a very short reply. 0.92. What is the ratio of the Cost of computers, communications and other services (% of commerical service exports) of Latvia in 2009 to that in 2010?
Offer a very short reply. 0.99. What is the ratio of the Cost of computers, communications and other services (% of commerical service exports) of Uganda in 2009 to that in 2010?
Keep it short and to the point. 0.86. What is the ratio of the Cost of computers, communications and other services (% of commerical service exports) of Kenya in 2009 to that in 2011?
Provide a succinct answer. 1.03. What is the ratio of the Cost of computers, communications and other services (% of commerical service exports) in Latvia in 2009 to that in 2011?
Offer a terse response. 1.02. What is the ratio of the Cost of computers, communications and other services (% of commerical service exports) in Uganda in 2009 to that in 2011?
Provide a short and direct response. 0.53. What is the ratio of the Cost of computers, communications and other services (% of commerical service exports) of Kenya in 2009 to that in 2012?
Provide a succinct answer. 1.05. What is the ratio of the Cost of computers, communications and other services (% of commerical service exports) in Latvia in 2009 to that in 2012?
Give a very brief answer. 0.93. What is the ratio of the Cost of computers, communications and other services (% of commerical service exports) in Uganda in 2009 to that in 2012?
Provide a succinct answer. 0.65. What is the ratio of the Cost of computers, communications and other services (% of commerical service exports) of Kenya in 2010 to that in 2011?
Your answer should be very brief. 1.11. What is the ratio of the Cost of computers, communications and other services (% of commerical service exports) in Latvia in 2010 to that in 2011?
Provide a succinct answer. 1.03. What is the ratio of the Cost of computers, communications and other services (% of commerical service exports) in Uganda in 2010 to that in 2011?
Offer a terse response. 0.62. What is the ratio of the Cost of computers, communications and other services (% of commerical service exports) in Kenya in 2010 to that in 2012?
Offer a very short reply. 1.13. What is the ratio of the Cost of computers, communications and other services (% of commerical service exports) in Latvia in 2010 to that in 2012?
Make the answer very short. 0.94. What is the ratio of the Cost of computers, communications and other services (% of commerical service exports) of Uganda in 2010 to that in 2012?
Provide a short and direct response. 0.75. What is the ratio of the Cost of computers, communications and other services (% of commerical service exports) of Kenya in 2011 to that in 2012?
Offer a terse response. 1.02. What is the ratio of the Cost of computers, communications and other services (% of commerical service exports) of Latvia in 2011 to that in 2012?
Ensure brevity in your answer.  0.91. What is the ratio of the Cost of computers, communications and other services (% of commerical service exports) of Uganda in 2011 to that in 2012?
Ensure brevity in your answer.  1.22. What is the difference between the highest and the second highest Cost of computers, communications and other services (% of commerical service exports) in Kenya?
Offer a very short reply. 5.51. What is the difference between the highest and the second highest Cost of computers, communications and other services (% of commerical service exports) of Latvia?
Provide a short and direct response. 2.22. What is the difference between the highest and the second highest Cost of computers, communications and other services (% of commerical service exports) of Uganda?
Offer a very short reply. 5.42. What is the difference between the highest and the lowest Cost of computers, communications and other services (% of commerical service exports) of Kenya?
Offer a terse response. 10.77. What is the difference between the highest and the lowest Cost of computers, communications and other services (% of commerical service exports) in Latvia?
Offer a terse response. 12.35. What is the difference between the highest and the lowest Cost of computers, communications and other services (% of commerical service exports) of Uganda?
Provide a short and direct response. 22.47. 